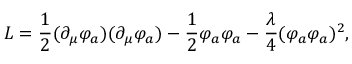Convert formula to latex. <formula><loc_0><loc_0><loc_500><loc_500>L = { \frac { 1 } { 2 } } ( \partial _ { \mu } \varphi _ { a } ) ( \partial _ { \mu } \varphi _ { a } ) - { \frac { 1 } { 2 } } \varphi _ { a } \varphi _ { a } - { \frac { \lambda } { 4 } } ( \varphi _ { a } \varphi _ { a } ) ^ { 2 } ,</formula> 